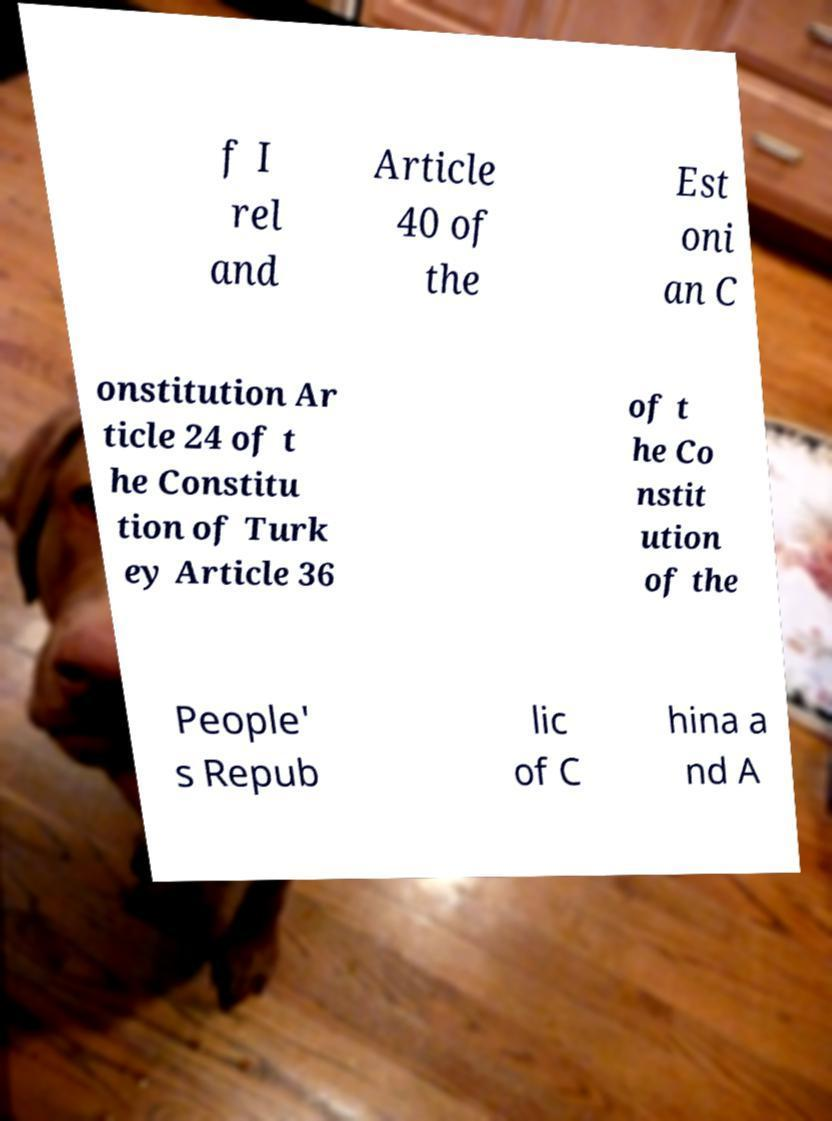Could you extract and type out the text from this image? f I rel and Article 40 of the Est oni an C onstitution Ar ticle 24 of t he Constitu tion of Turk ey Article 36 of t he Co nstit ution of the People' s Repub lic of C hina a nd A 